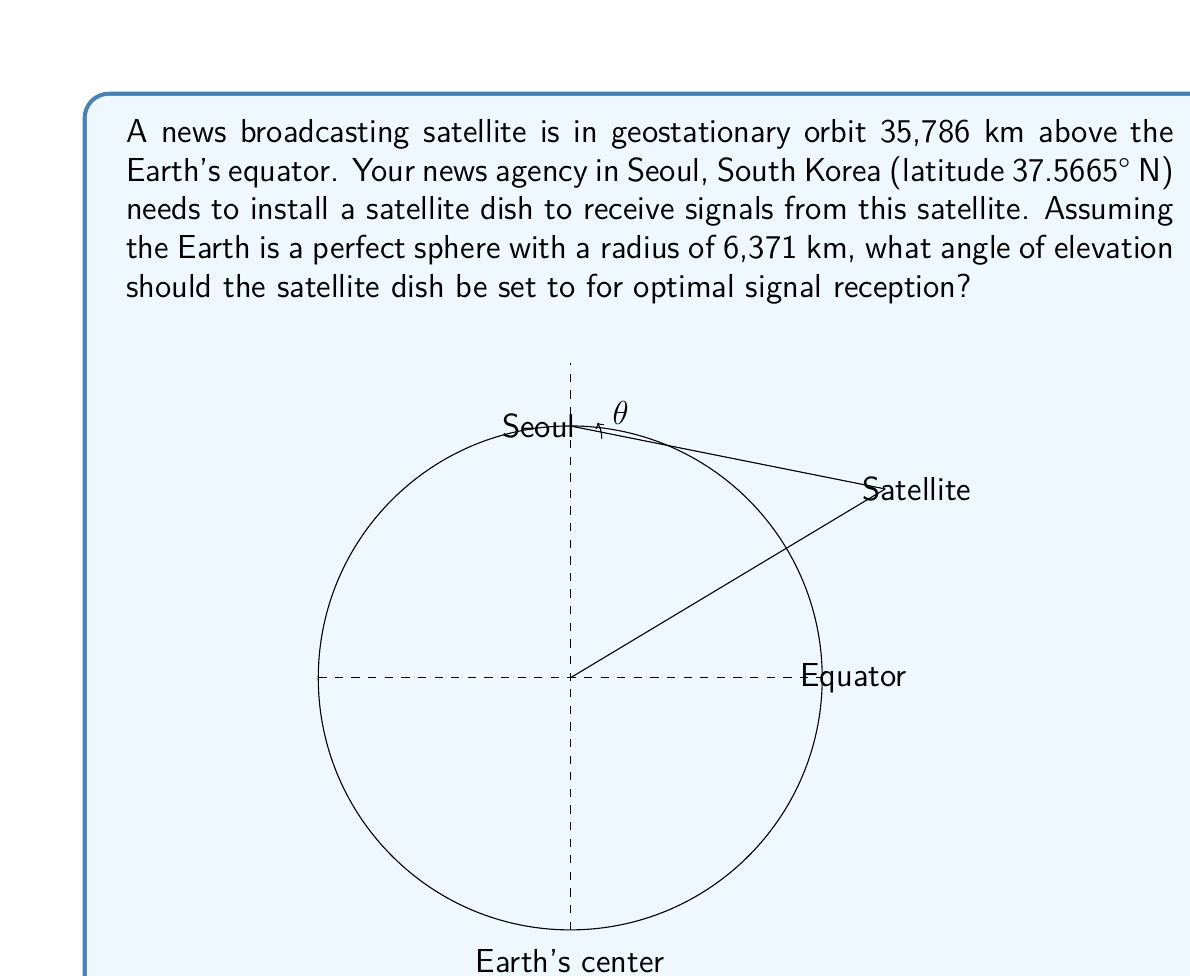What is the answer to this math problem? To solve this problem, we'll use the following steps:

1) First, we need to calculate the distance from the center of the Earth to the satellite:
   $$R_s = 6371 \text{ km} + 35786 \text{ km} = 42157 \text{ km}$$

2) Next, we calculate the central angle between Seoul and the point directly beneath the satellite on the equator. The difference in latitude is 37.5665°, so:
   $$\alpha = 90^\circ - 37.5665^\circ = 52.4335^\circ$$

3) Now we can use the law of cosines in the triangle formed by the Earth's center, Seoul, and the satellite:

   $$d^2 = R_e^2 + R_s^2 - 2R_eR_s\cos(\alpha)$$

   Where $d$ is the distance from Seoul to the satellite, $R_e$ is Earth's radius, and $R_s$ is the distance from Earth's center to the satellite.

4) Substituting the values:
   $$d^2 = 6371^2 + 42157^2 - 2(6371)(42157)\cos(52.4335^\circ)$$

5) Solving for $d$:
   $$d \approx 37640.7 \text{ km}$$

6) Finally, we can use trigonometry to find the elevation angle $\theta$:

   $$\sin(\theta) = \frac{R_s\sin(\alpha)}{d}$$

7) Substituting the values:
   $$\theta = \arcsin\left(\frac{42157\sin(52.4335^\circ)}{37640.7}\right)$$

8) Solving for $\theta$:
   $$\theta \approx 45.03^\circ$$

Therefore, the satellite dish should be elevated at an angle of approximately 45.03° for optimal signal reception.
Answer: The angle of elevation for the satellite dish should be set to approximately $45.03^\circ$. 